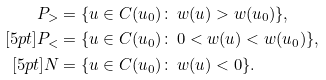<formula> <loc_0><loc_0><loc_500><loc_500>P _ { > } & = \{ u \in C ( u _ { 0 } ) \colon \, w ( u ) > w ( u _ { 0 } ) \} , \\ [ 5 p t ] P _ { < } & = \{ u \in C ( u _ { 0 } ) \colon \, 0 < w ( u ) < w ( u _ { 0 } ) \} , \\ [ 5 p t ] N & = \{ u \in C ( u _ { 0 } ) \colon \, w ( u ) < 0 \} .</formula> 